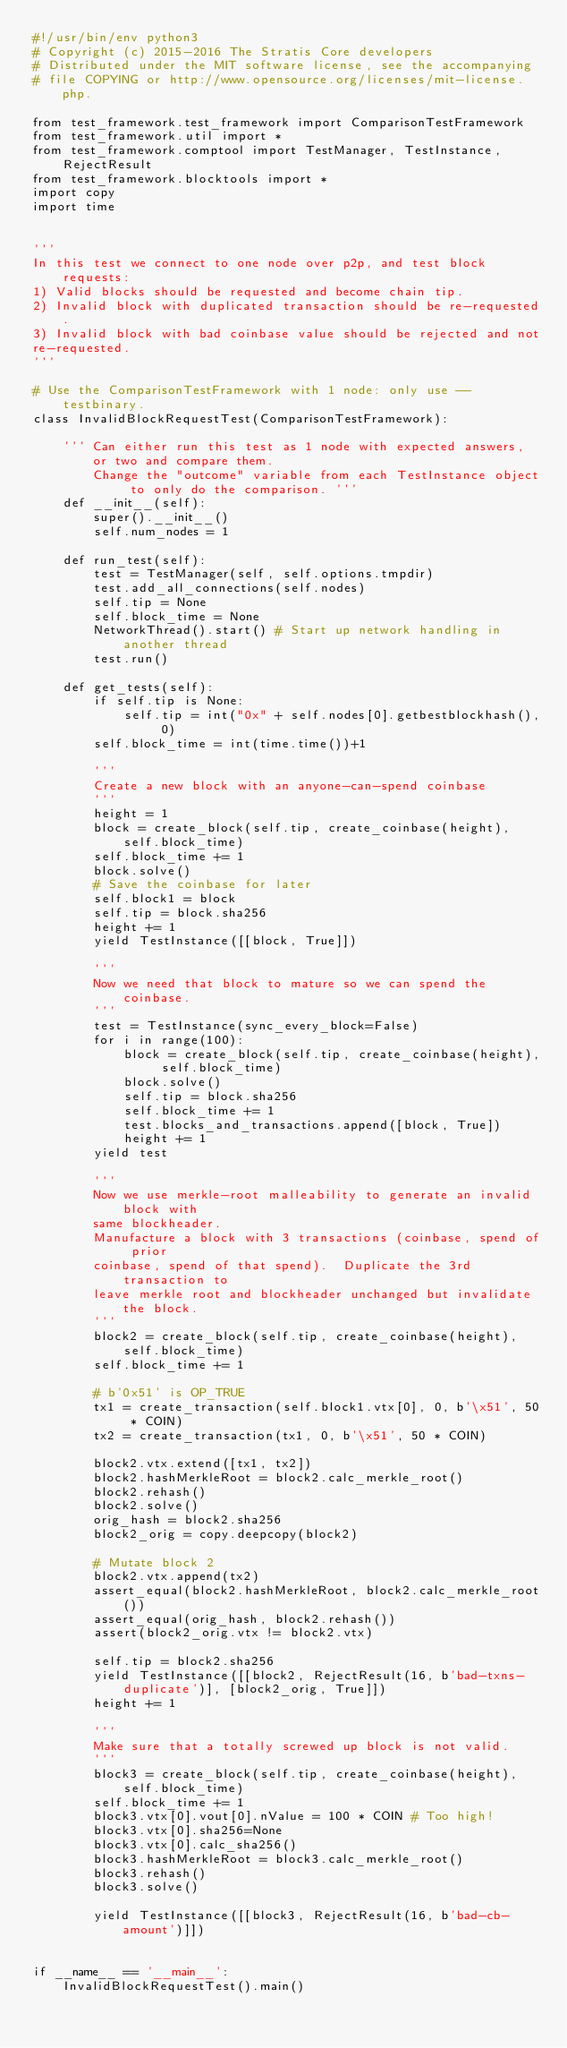<code> <loc_0><loc_0><loc_500><loc_500><_Python_>#!/usr/bin/env python3
# Copyright (c) 2015-2016 The Stratis Core developers
# Distributed under the MIT software license, see the accompanying
# file COPYING or http://www.opensource.org/licenses/mit-license.php.

from test_framework.test_framework import ComparisonTestFramework
from test_framework.util import *
from test_framework.comptool import TestManager, TestInstance, RejectResult
from test_framework.blocktools import *
import copy
import time


'''
In this test we connect to one node over p2p, and test block requests:
1) Valid blocks should be requested and become chain tip.
2) Invalid block with duplicated transaction should be re-requested.
3) Invalid block with bad coinbase value should be rejected and not
re-requested.
'''

# Use the ComparisonTestFramework with 1 node: only use --testbinary.
class InvalidBlockRequestTest(ComparisonTestFramework):

    ''' Can either run this test as 1 node with expected answers, or two and compare them. 
        Change the "outcome" variable from each TestInstance object to only do the comparison. '''
    def __init__(self):
        super().__init__()
        self.num_nodes = 1

    def run_test(self):
        test = TestManager(self, self.options.tmpdir)
        test.add_all_connections(self.nodes)
        self.tip = None
        self.block_time = None
        NetworkThread().start() # Start up network handling in another thread
        test.run()

    def get_tests(self):
        if self.tip is None:
            self.tip = int("0x" + self.nodes[0].getbestblockhash(), 0)
        self.block_time = int(time.time())+1

        '''
        Create a new block with an anyone-can-spend coinbase
        '''
        height = 1
        block = create_block(self.tip, create_coinbase(height), self.block_time)
        self.block_time += 1
        block.solve()
        # Save the coinbase for later
        self.block1 = block
        self.tip = block.sha256
        height += 1
        yield TestInstance([[block, True]])

        '''
        Now we need that block to mature so we can spend the coinbase.
        '''
        test = TestInstance(sync_every_block=False)
        for i in range(100):
            block = create_block(self.tip, create_coinbase(height), self.block_time)
            block.solve()
            self.tip = block.sha256
            self.block_time += 1
            test.blocks_and_transactions.append([block, True])
            height += 1
        yield test

        '''
        Now we use merkle-root malleability to generate an invalid block with
        same blockheader.
        Manufacture a block with 3 transactions (coinbase, spend of prior
        coinbase, spend of that spend).  Duplicate the 3rd transaction to 
        leave merkle root and blockheader unchanged but invalidate the block.
        '''
        block2 = create_block(self.tip, create_coinbase(height), self.block_time)
        self.block_time += 1

        # b'0x51' is OP_TRUE
        tx1 = create_transaction(self.block1.vtx[0], 0, b'\x51', 50 * COIN)
        tx2 = create_transaction(tx1, 0, b'\x51', 50 * COIN)

        block2.vtx.extend([tx1, tx2])
        block2.hashMerkleRoot = block2.calc_merkle_root()
        block2.rehash()
        block2.solve()
        orig_hash = block2.sha256
        block2_orig = copy.deepcopy(block2)

        # Mutate block 2
        block2.vtx.append(tx2)
        assert_equal(block2.hashMerkleRoot, block2.calc_merkle_root())
        assert_equal(orig_hash, block2.rehash())
        assert(block2_orig.vtx != block2.vtx)

        self.tip = block2.sha256
        yield TestInstance([[block2, RejectResult(16, b'bad-txns-duplicate')], [block2_orig, True]])
        height += 1

        '''
        Make sure that a totally screwed up block is not valid.
        '''
        block3 = create_block(self.tip, create_coinbase(height), self.block_time)
        self.block_time += 1
        block3.vtx[0].vout[0].nValue = 100 * COIN # Too high!
        block3.vtx[0].sha256=None
        block3.vtx[0].calc_sha256()
        block3.hashMerkleRoot = block3.calc_merkle_root()
        block3.rehash()
        block3.solve()

        yield TestInstance([[block3, RejectResult(16, b'bad-cb-amount')]])


if __name__ == '__main__':
    InvalidBlockRequestTest().main()
</code> 